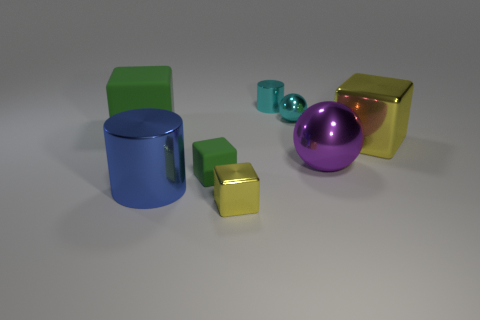Is there a blue object that has the same shape as the large yellow metal object?
Your answer should be compact. No. The thing that is behind the large purple thing and to the right of the tiny cyan metallic ball has what shape?
Your answer should be compact. Cube. What number of other tiny cyan balls have the same material as the small sphere?
Give a very brief answer. 0. Are there fewer small metallic cubes behind the tiny cylinder than big rubber cubes?
Your response must be concise. Yes. Is there a shiny cylinder in front of the cylinder left of the small green matte block?
Keep it short and to the point. No. Are there any other things that are the same shape as the large purple thing?
Your response must be concise. Yes. Do the cyan metal ball and the blue metallic cylinder have the same size?
Your response must be concise. No. What is the material of the sphere that is in front of the yellow metallic thing behind the matte cube in front of the big matte object?
Your answer should be very brief. Metal. Are there the same number of blocks that are right of the blue metal cylinder and large objects?
Your answer should be compact. No. Is there anything else that has the same size as the blue metal thing?
Offer a very short reply. Yes. 